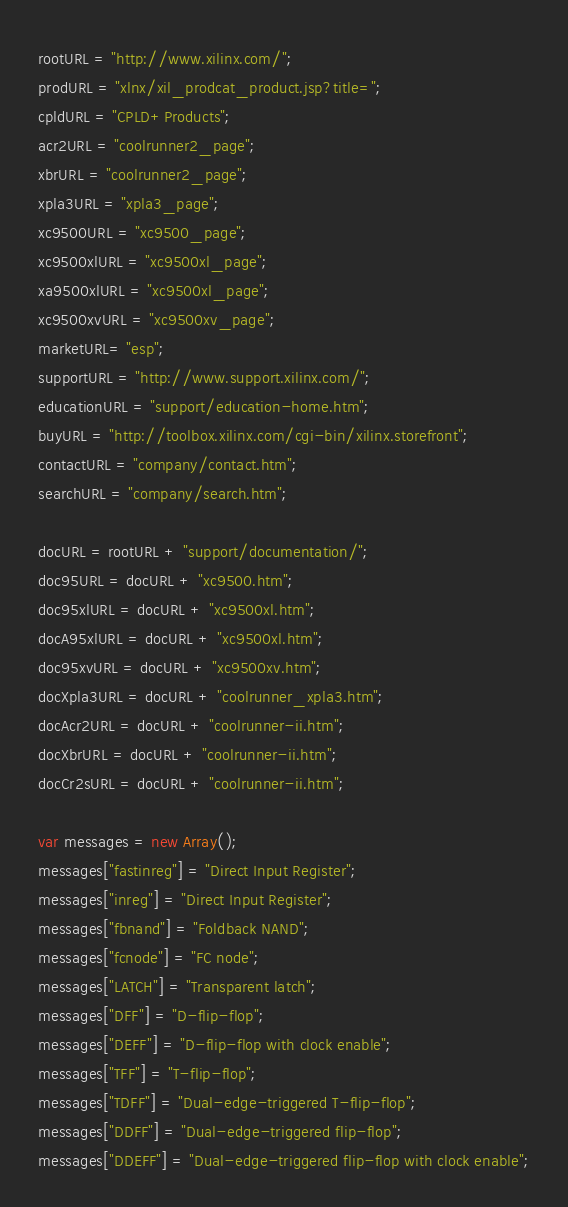<code> <loc_0><loc_0><loc_500><loc_500><_JavaScript_>rootURL = "http://www.xilinx.com/";
prodURL = "xlnx/xil_prodcat_product.jsp?title=";
cpldURL = "CPLD+Products";
acr2URL = "coolrunner2_page";
xbrURL = "coolrunner2_page";
xpla3URL = "xpla3_page";
xc9500URL = "xc9500_page";
xc9500xlURL = "xc9500xl_page";
xa9500xlURL = "xc9500xl_page";
xc9500xvURL = "xc9500xv_page";
marketURL= "esp";
supportURL = "http://www.support.xilinx.com/";
educationURL = "support/education-home.htm";
buyURL = "http://toolbox.xilinx.com/cgi-bin/xilinx.storefront";
contactURL = "company/contact.htm";
searchURL = "company/search.htm";

docURL = rootURL + "support/documentation/";
doc95URL = docURL + "xc9500.htm";
doc95xlURL = docURL + "xc9500xl.htm";
docA95xlURL = docURL + "xc9500xl.htm";
doc95xvURL = docURL + "xc9500xv.htm";
docXpla3URL = docURL + "coolrunner_xpla3.htm";
docAcr2URL = docURL + "coolrunner-ii.htm";
docXbrURL = docURL + "coolrunner-ii.htm";
docCr2sURL = docURL + "coolrunner-ii.htm";

var messages = new Array();
messages["fastinreg"] = "Direct Input Register";
messages["inreg"] = "Direct Input Register";
messages["fbnand"] = "Foldback NAND";
messages["fcnode"] = "FC node";
messages["LATCH"] = "Transparent latch";
messages["DFF"] = "D-flip-flop";
messages["DEFF"] = "D-flip-flop with clock enable";
messages["TFF"] = "T-flip-flop";
messages["TDFF"] = "Dual-edge-triggered T-flip-flop";
messages["DDFF"] = "Dual-edge-triggered flip-flop";
messages["DDEFF"] = "Dual-edge-triggered flip-flop with clock enable";
</code> 